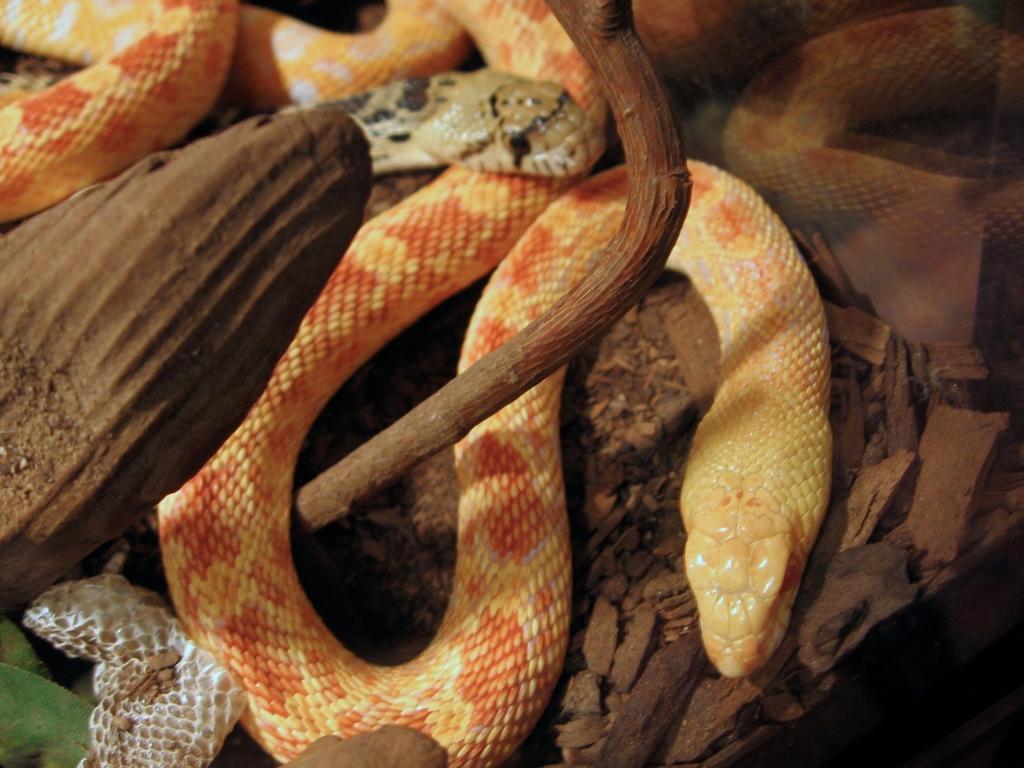Please provide a concise description of this image. In this picture I can see snakes and there are stones. 